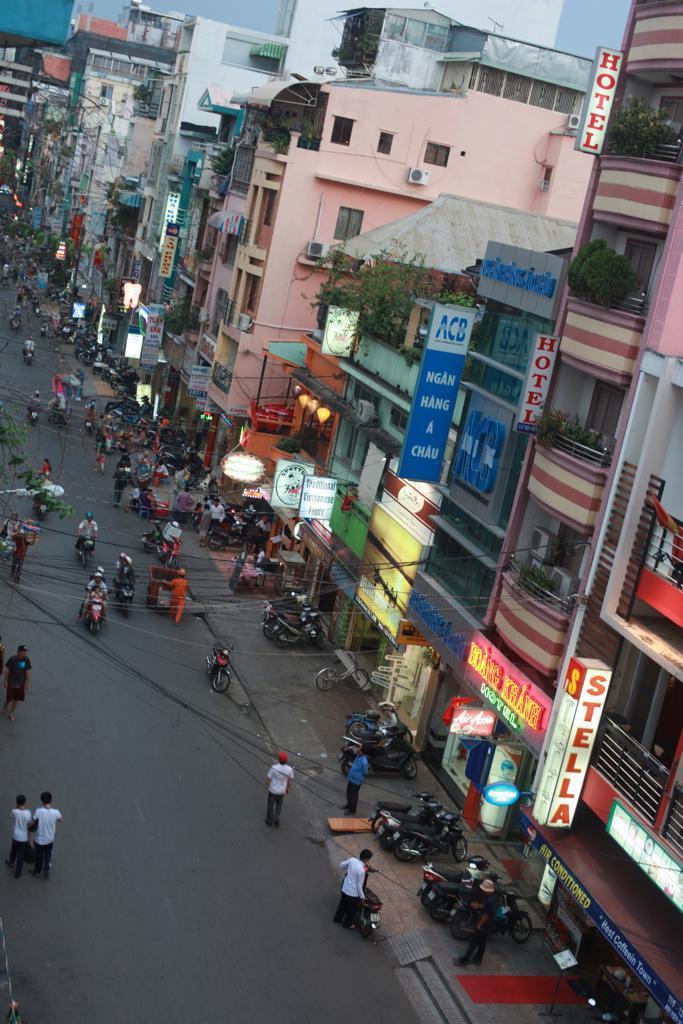Please provide a concise description of this image. In this picture we can see buildings, boards, plants, lights, bikes, and people. There is a road. 